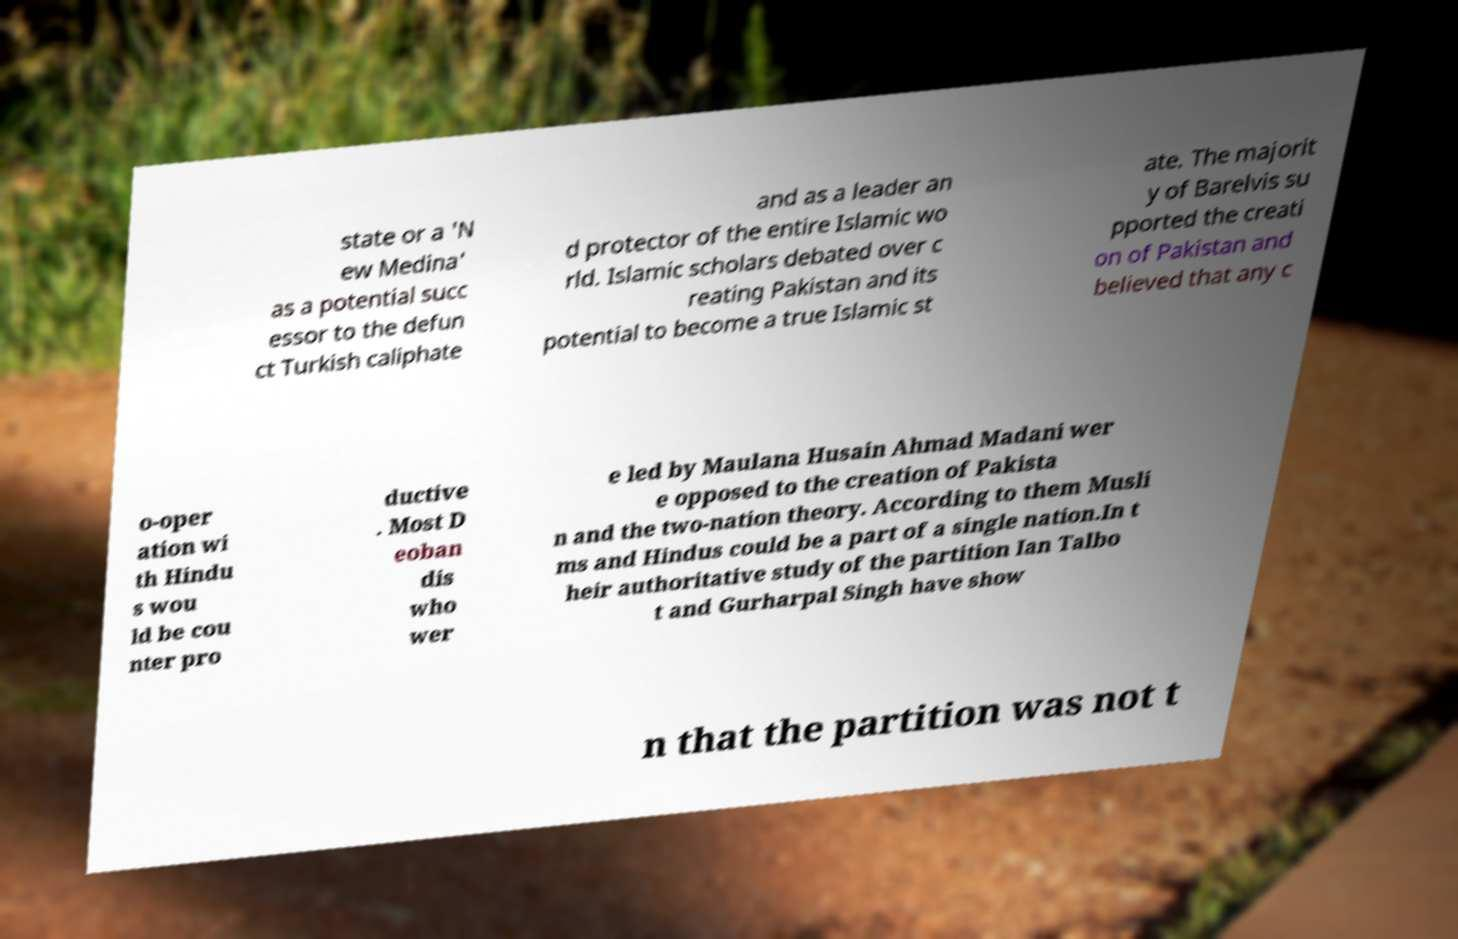Please read and relay the text visible in this image. What does it say? state or a 'N ew Medina' as a potential succ essor to the defun ct Turkish caliphate and as a leader an d protector of the entire Islamic wo rld. Islamic scholars debated over c reating Pakistan and its potential to become a true Islamic st ate. The majorit y of Barelvis su pported the creati on of Pakistan and believed that any c o-oper ation wi th Hindu s wou ld be cou nter pro ductive . Most D eoban dis who wer e led by Maulana Husain Ahmad Madani wer e opposed to the creation of Pakista n and the two-nation theory. According to them Musli ms and Hindus could be a part of a single nation.In t heir authoritative study of the partition Ian Talbo t and Gurharpal Singh have show n that the partition was not t 